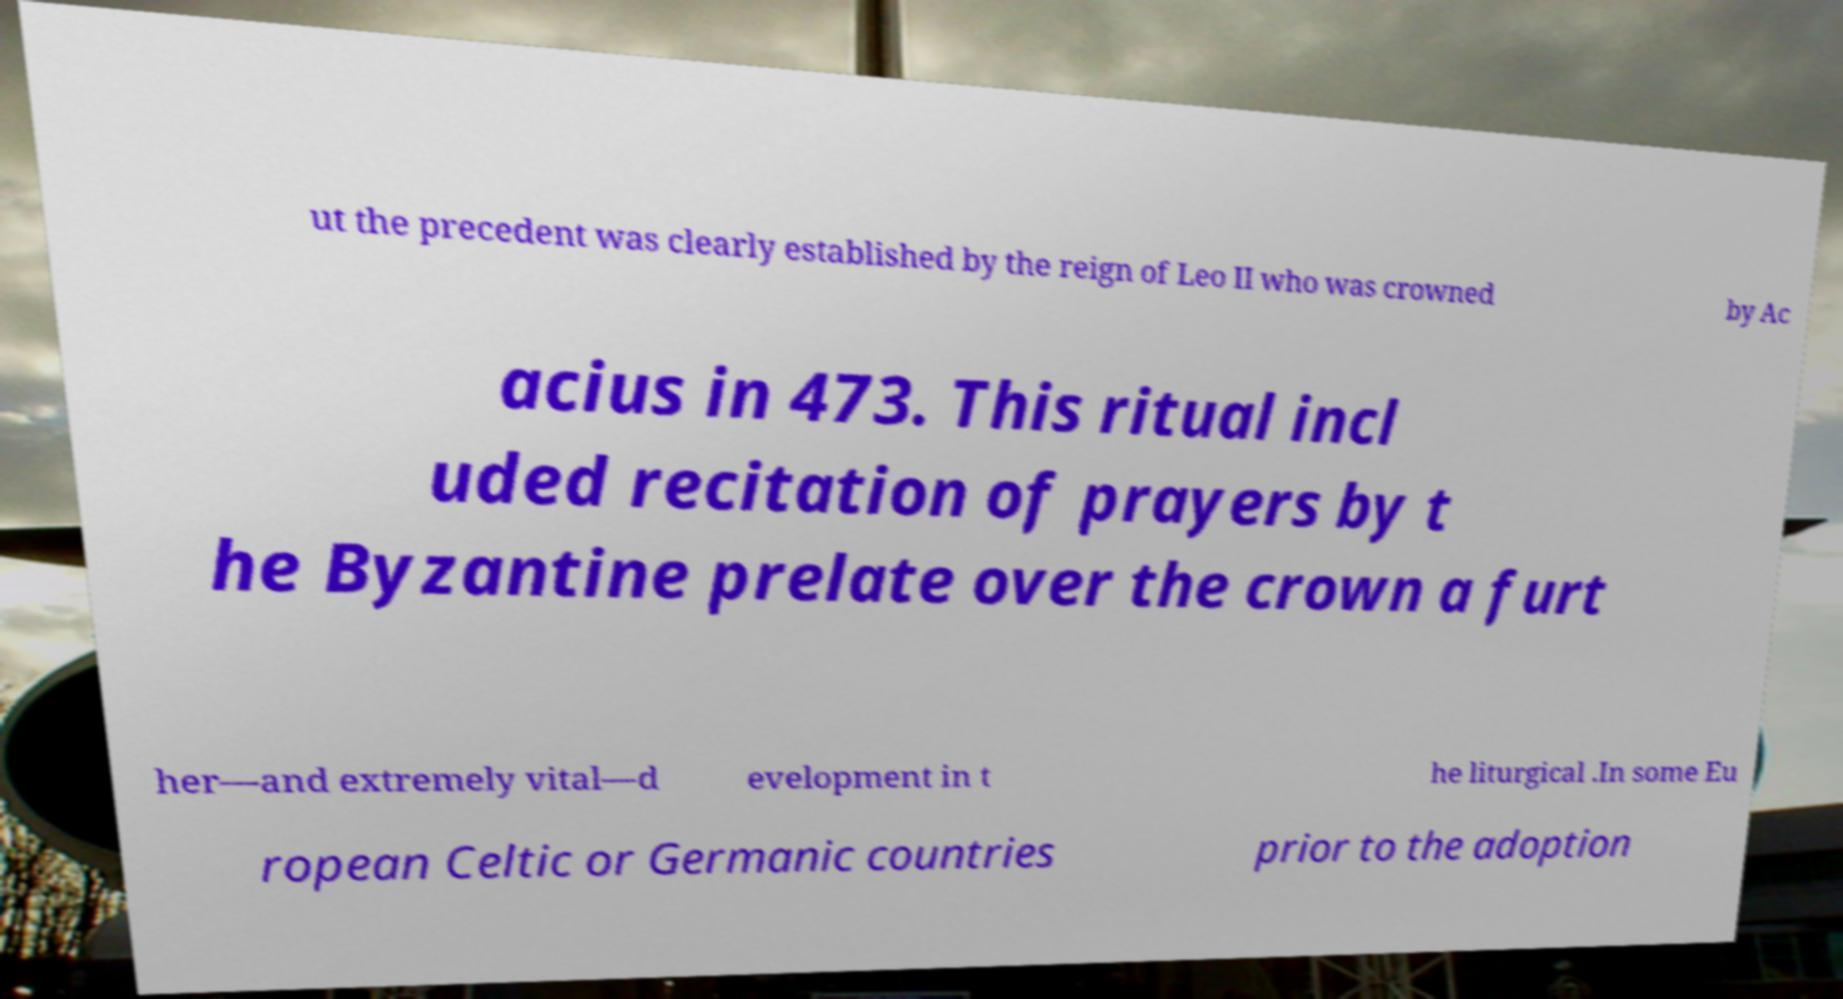Can you read and provide the text displayed in the image?This photo seems to have some interesting text. Can you extract and type it out for me? ut the precedent was clearly established by the reign of Leo II who was crowned by Ac acius in 473. This ritual incl uded recitation of prayers by t he Byzantine prelate over the crown a furt her—and extremely vital—d evelopment in t he liturgical .In some Eu ropean Celtic or Germanic countries prior to the adoption 